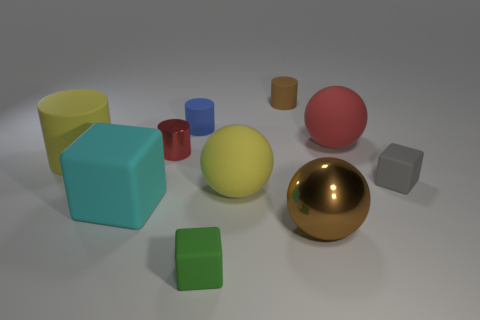What can you infer about the setting or the context from this image? The image seems to depict a simple scene set up for either a graphical rendering test or a study of shapes and colors. The neutral background and even lighting suggest a controlled environment, potentially used for educational or demonstration purposes. 